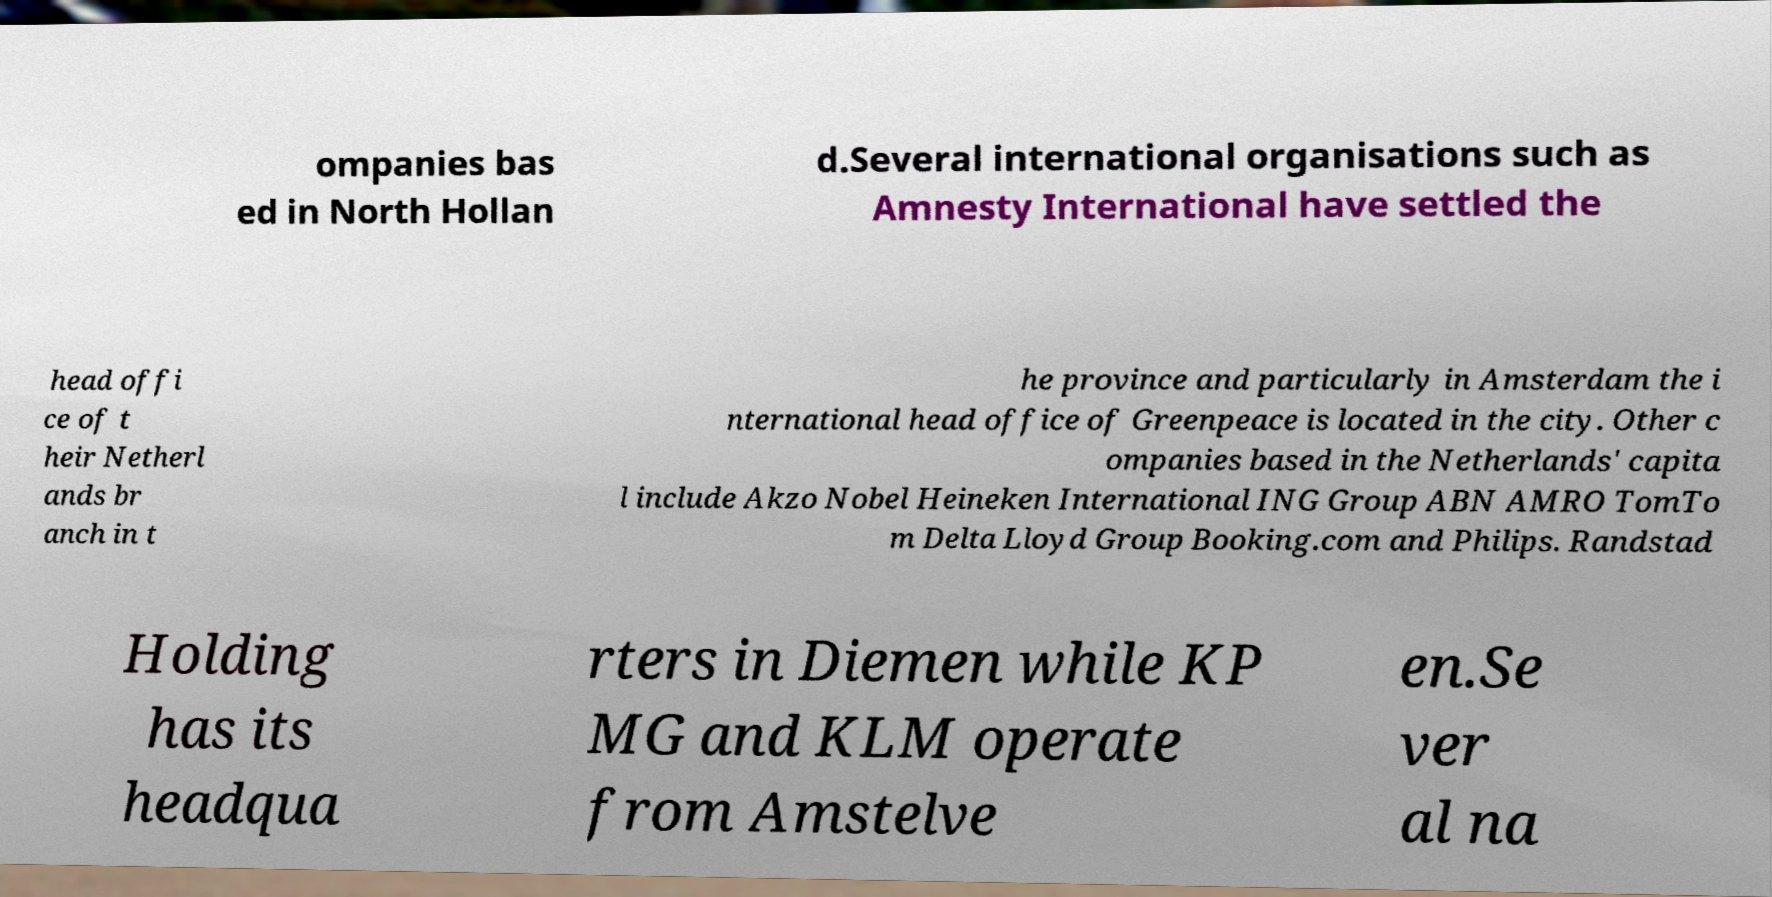I need the written content from this picture converted into text. Can you do that? ompanies bas ed in North Hollan d.Several international organisations such as Amnesty International have settled the head offi ce of t heir Netherl ands br anch in t he province and particularly in Amsterdam the i nternational head office of Greenpeace is located in the city. Other c ompanies based in the Netherlands' capita l include Akzo Nobel Heineken International ING Group ABN AMRO TomTo m Delta Lloyd Group Booking.com and Philips. Randstad Holding has its headqua rters in Diemen while KP MG and KLM operate from Amstelve en.Se ver al na 